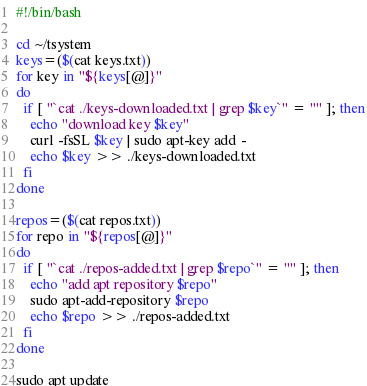Convert code to text. <code><loc_0><loc_0><loc_500><loc_500><_Bash_>#!/bin/bash

cd ~/tsystem
keys=($(cat keys.txt))
for key in "${keys[@]}"
do
  if [ "`cat ./keys-downloaded.txt | grep $key`" = "" ]; then
    echo "download key $key"
    curl -fsSL $key | sudo apt-key add -
    echo $key >> ./keys-downloaded.txt
  fi
done

repos=($(cat repos.txt))
for repo in "${repos[@]}"
do
  if [ "`cat ./repos-added.txt | grep $repo`" = "" ]; then
    echo "add apt repository $repo"
    sudo apt-add-repository $repo
    echo $repo >> ./repos-added.txt
  fi
done

sudo apt update
</code> 